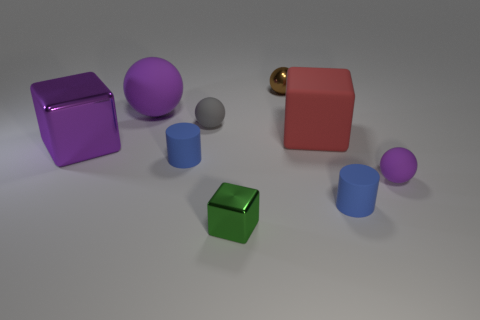Is there anything else that has the same size as the red rubber cube?
Offer a very short reply. Yes. There is a rubber cylinder to the left of the small brown object; does it have the same color as the big matte sphere?
Your answer should be very brief. No. How many cubes are big red matte things or shiny things?
Provide a succinct answer. 3. What is the shape of the shiny object that is to the right of the tiny green object?
Your answer should be compact. Sphere. There is a tiny object that is behind the large rubber thing that is on the left side of the tiny metal object in front of the small purple object; what is its color?
Your answer should be very brief. Brown. Are the red block and the big ball made of the same material?
Your answer should be very brief. Yes. How many blue objects are either spheres or small matte objects?
Offer a very short reply. 2. What number of tiny shiny spheres are behind the big ball?
Keep it short and to the point. 1. Are there more gray objects than big blue shiny blocks?
Your answer should be very brief. Yes. There is a tiny metal thing in front of the small rubber sphere that is in front of the purple metal object; what shape is it?
Your answer should be very brief. Cube. 